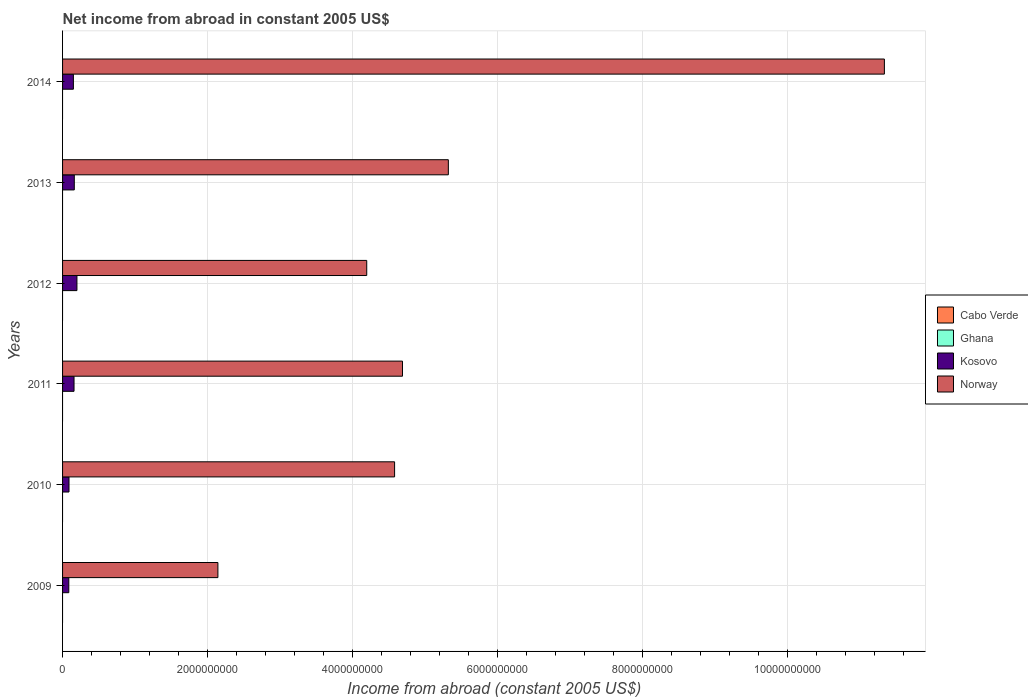Are the number of bars per tick equal to the number of legend labels?
Give a very brief answer. No. How many bars are there on the 3rd tick from the top?
Provide a short and direct response. 2. What is the label of the 2nd group of bars from the top?
Provide a succinct answer. 2013. Across all years, what is the maximum net income from abroad in Norway?
Make the answer very short. 1.13e+1. Across all years, what is the minimum net income from abroad in Kosovo?
Offer a very short reply. 8.59e+07. What is the total net income from abroad in Norway in the graph?
Your response must be concise. 3.22e+1. What is the difference between the net income from abroad in Norway in 2010 and that in 2014?
Your answer should be very brief. -6.75e+09. What is the difference between the net income from abroad in Kosovo in 2011 and the net income from abroad in Ghana in 2014?
Offer a terse response. 1.58e+08. What is the average net income from abroad in Ghana per year?
Offer a very short reply. 0. In the year 2014, what is the difference between the net income from abroad in Kosovo and net income from abroad in Norway?
Offer a terse response. -1.12e+1. In how many years, is the net income from abroad in Ghana greater than 2400000000 US$?
Make the answer very short. 0. What is the ratio of the net income from abroad in Norway in 2010 to that in 2012?
Provide a succinct answer. 1.09. What is the difference between the highest and the second highest net income from abroad in Norway?
Give a very brief answer. 6.01e+09. What is the difference between the highest and the lowest net income from abroad in Kosovo?
Your response must be concise. 1.12e+08. Is the sum of the net income from abroad in Norway in 2011 and 2014 greater than the maximum net income from abroad in Ghana across all years?
Keep it short and to the point. Yes. Is it the case that in every year, the sum of the net income from abroad in Norway and net income from abroad in Cabo Verde is greater than the sum of net income from abroad in Ghana and net income from abroad in Kosovo?
Make the answer very short. No. Is it the case that in every year, the sum of the net income from abroad in Kosovo and net income from abroad in Norway is greater than the net income from abroad in Cabo Verde?
Make the answer very short. Yes. How many bars are there?
Provide a short and direct response. 12. What is the difference between two consecutive major ticks on the X-axis?
Your response must be concise. 2.00e+09. Does the graph contain any zero values?
Ensure brevity in your answer.  Yes. What is the title of the graph?
Ensure brevity in your answer.  Net income from abroad in constant 2005 US$. What is the label or title of the X-axis?
Provide a short and direct response. Income from abroad (constant 2005 US$). What is the label or title of the Y-axis?
Provide a succinct answer. Years. What is the Income from abroad (constant 2005 US$) of Cabo Verde in 2009?
Ensure brevity in your answer.  0. What is the Income from abroad (constant 2005 US$) in Kosovo in 2009?
Give a very brief answer. 8.59e+07. What is the Income from abroad (constant 2005 US$) of Norway in 2009?
Your answer should be compact. 2.14e+09. What is the Income from abroad (constant 2005 US$) of Ghana in 2010?
Provide a succinct answer. 0. What is the Income from abroad (constant 2005 US$) of Kosovo in 2010?
Give a very brief answer. 8.88e+07. What is the Income from abroad (constant 2005 US$) in Norway in 2010?
Ensure brevity in your answer.  4.58e+09. What is the Income from abroad (constant 2005 US$) in Cabo Verde in 2011?
Give a very brief answer. 0. What is the Income from abroad (constant 2005 US$) in Ghana in 2011?
Provide a succinct answer. 0. What is the Income from abroad (constant 2005 US$) of Kosovo in 2011?
Provide a succinct answer. 1.58e+08. What is the Income from abroad (constant 2005 US$) in Norway in 2011?
Your answer should be very brief. 4.69e+09. What is the Income from abroad (constant 2005 US$) in Kosovo in 2012?
Your answer should be very brief. 1.98e+08. What is the Income from abroad (constant 2005 US$) of Norway in 2012?
Offer a terse response. 4.19e+09. What is the Income from abroad (constant 2005 US$) of Cabo Verde in 2013?
Offer a very short reply. 0. What is the Income from abroad (constant 2005 US$) in Ghana in 2013?
Provide a short and direct response. 0. What is the Income from abroad (constant 2005 US$) of Kosovo in 2013?
Provide a short and direct response. 1.62e+08. What is the Income from abroad (constant 2005 US$) in Norway in 2013?
Give a very brief answer. 5.32e+09. What is the Income from abroad (constant 2005 US$) of Ghana in 2014?
Offer a terse response. 0. What is the Income from abroad (constant 2005 US$) of Kosovo in 2014?
Your answer should be very brief. 1.49e+08. What is the Income from abroad (constant 2005 US$) in Norway in 2014?
Offer a very short reply. 1.13e+1. Across all years, what is the maximum Income from abroad (constant 2005 US$) in Kosovo?
Your response must be concise. 1.98e+08. Across all years, what is the maximum Income from abroad (constant 2005 US$) of Norway?
Offer a very short reply. 1.13e+1. Across all years, what is the minimum Income from abroad (constant 2005 US$) of Kosovo?
Your answer should be very brief. 8.59e+07. Across all years, what is the minimum Income from abroad (constant 2005 US$) in Norway?
Provide a short and direct response. 2.14e+09. What is the total Income from abroad (constant 2005 US$) of Ghana in the graph?
Offer a terse response. 0. What is the total Income from abroad (constant 2005 US$) of Kosovo in the graph?
Offer a very short reply. 8.42e+08. What is the total Income from abroad (constant 2005 US$) in Norway in the graph?
Your response must be concise. 3.22e+1. What is the difference between the Income from abroad (constant 2005 US$) of Kosovo in 2009 and that in 2010?
Make the answer very short. -2.94e+06. What is the difference between the Income from abroad (constant 2005 US$) of Norway in 2009 and that in 2010?
Offer a very short reply. -2.44e+09. What is the difference between the Income from abroad (constant 2005 US$) in Kosovo in 2009 and that in 2011?
Ensure brevity in your answer.  -7.23e+07. What is the difference between the Income from abroad (constant 2005 US$) of Norway in 2009 and that in 2011?
Provide a succinct answer. -2.54e+09. What is the difference between the Income from abroad (constant 2005 US$) of Kosovo in 2009 and that in 2012?
Offer a very short reply. -1.12e+08. What is the difference between the Income from abroad (constant 2005 US$) of Norway in 2009 and that in 2012?
Give a very brief answer. -2.05e+09. What is the difference between the Income from abroad (constant 2005 US$) in Kosovo in 2009 and that in 2013?
Make the answer very short. -7.58e+07. What is the difference between the Income from abroad (constant 2005 US$) in Norway in 2009 and that in 2013?
Provide a short and direct response. -3.18e+09. What is the difference between the Income from abroad (constant 2005 US$) in Kosovo in 2009 and that in 2014?
Your answer should be compact. -6.34e+07. What is the difference between the Income from abroad (constant 2005 US$) of Norway in 2009 and that in 2014?
Offer a very short reply. -9.19e+09. What is the difference between the Income from abroad (constant 2005 US$) of Kosovo in 2010 and that in 2011?
Keep it short and to the point. -6.94e+07. What is the difference between the Income from abroad (constant 2005 US$) in Norway in 2010 and that in 2011?
Provide a succinct answer. -1.09e+08. What is the difference between the Income from abroad (constant 2005 US$) of Kosovo in 2010 and that in 2012?
Your answer should be compact. -1.09e+08. What is the difference between the Income from abroad (constant 2005 US$) in Norway in 2010 and that in 2012?
Ensure brevity in your answer.  3.84e+08. What is the difference between the Income from abroad (constant 2005 US$) in Kosovo in 2010 and that in 2013?
Your answer should be compact. -7.29e+07. What is the difference between the Income from abroad (constant 2005 US$) in Norway in 2010 and that in 2013?
Provide a succinct answer. -7.41e+08. What is the difference between the Income from abroad (constant 2005 US$) in Kosovo in 2010 and that in 2014?
Your response must be concise. -6.05e+07. What is the difference between the Income from abroad (constant 2005 US$) in Norway in 2010 and that in 2014?
Give a very brief answer. -6.75e+09. What is the difference between the Income from abroad (constant 2005 US$) in Kosovo in 2011 and that in 2012?
Make the answer very short. -3.99e+07. What is the difference between the Income from abroad (constant 2005 US$) of Norway in 2011 and that in 2012?
Your response must be concise. 4.93e+08. What is the difference between the Income from abroad (constant 2005 US$) of Kosovo in 2011 and that in 2013?
Give a very brief answer. -3.47e+06. What is the difference between the Income from abroad (constant 2005 US$) in Norway in 2011 and that in 2013?
Your response must be concise. -6.32e+08. What is the difference between the Income from abroad (constant 2005 US$) of Kosovo in 2011 and that in 2014?
Your answer should be compact. 8.91e+06. What is the difference between the Income from abroad (constant 2005 US$) of Norway in 2011 and that in 2014?
Give a very brief answer. -6.64e+09. What is the difference between the Income from abroad (constant 2005 US$) of Kosovo in 2012 and that in 2013?
Give a very brief answer. 3.64e+07. What is the difference between the Income from abroad (constant 2005 US$) in Norway in 2012 and that in 2013?
Offer a very short reply. -1.13e+09. What is the difference between the Income from abroad (constant 2005 US$) of Kosovo in 2012 and that in 2014?
Your answer should be compact. 4.88e+07. What is the difference between the Income from abroad (constant 2005 US$) in Norway in 2012 and that in 2014?
Ensure brevity in your answer.  -7.14e+09. What is the difference between the Income from abroad (constant 2005 US$) in Kosovo in 2013 and that in 2014?
Give a very brief answer. 1.24e+07. What is the difference between the Income from abroad (constant 2005 US$) in Norway in 2013 and that in 2014?
Provide a short and direct response. -6.01e+09. What is the difference between the Income from abroad (constant 2005 US$) in Kosovo in 2009 and the Income from abroad (constant 2005 US$) in Norway in 2010?
Make the answer very short. -4.49e+09. What is the difference between the Income from abroad (constant 2005 US$) in Kosovo in 2009 and the Income from abroad (constant 2005 US$) in Norway in 2011?
Your response must be concise. -4.60e+09. What is the difference between the Income from abroad (constant 2005 US$) in Kosovo in 2009 and the Income from abroad (constant 2005 US$) in Norway in 2012?
Your response must be concise. -4.11e+09. What is the difference between the Income from abroad (constant 2005 US$) in Kosovo in 2009 and the Income from abroad (constant 2005 US$) in Norway in 2013?
Your answer should be very brief. -5.23e+09. What is the difference between the Income from abroad (constant 2005 US$) in Kosovo in 2009 and the Income from abroad (constant 2005 US$) in Norway in 2014?
Offer a very short reply. -1.12e+1. What is the difference between the Income from abroad (constant 2005 US$) of Kosovo in 2010 and the Income from abroad (constant 2005 US$) of Norway in 2011?
Keep it short and to the point. -4.60e+09. What is the difference between the Income from abroad (constant 2005 US$) in Kosovo in 2010 and the Income from abroad (constant 2005 US$) in Norway in 2012?
Provide a succinct answer. -4.10e+09. What is the difference between the Income from abroad (constant 2005 US$) in Kosovo in 2010 and the Income from abroad (constant 2005 US$) in Norway in 2013?
Your answer should be compact. -5.23e+09. What is the difference between the Income from abroad (constant 2005 US$) of Kosovo in 2010 and the Income from abroad (constant 2005 US$) of Norway in 2014?
Your answer should be compact. -1.12e+1. What is the difference between the Income from abroad (constant 2005 US$) of Kosovo in 2011 and the Income from abroad (constant 2005 US$) of Norway in 2012?
Ensure brevity in your answer.  -4.04e+09. What is the difference between the Income from abroad (constant 2005 US$) of Kosovo in 2011 and the Income from abroad (constant 2005 US$) of Norway in 2013?
Your response must be concise. -5.16e+09. What is the difference between the Income from abroad (constant 2005 US$) in Kosovo in 2011 and the Income from abroad (constant 2005 US$) in Norway in 2014?
Your response must be concise. -1.12e+1. What is the difference between the Income from abroad (constant 2005 US$) in Kosovo in 2012 and the Income from abroad (constant 2005 US$) in Norway in 2013?
Give a very brief answer. -5.12e+09. What is the difference between the Income from abroad (constant 2005 US$) in Kosovo in 2012 and the Income from abroad (constant 2005 US$) in Norway in 2014?
Make the answer very short. -1.11e+1. What is the difference between the Income from abroad (constant 2005 US$) in Kosovo in 2013 and the Income from abroad (constant 2005 US$) in Norway in 2014?
Ensure brevity in your answer.  -1.12e+1. What is the average Income from abroad (constant 2005 US$) of Ghana per year?
Give a very brief answer. 0. What is the average Income from abroad (constant 2005 US$) in Kosovo per year?
Give a very brief answer. 1.40e+08. What is the average Income from abroad (constant 2005 US$) in Norway per year?
Provide a succinct answer. 5.37e+09. In the year 2009, what is the difference between the Income from abroad (constant 2005 US$) of Kosovo and Income from abroad (constant 2005 US$) of Norway?
Keep it short and to the point. -2.06e+09. In the year 2010, what is the difference between the Income from abroad (constant 2005 US$) in Kosovo and Income from abroad (constant 2005 US$) in Norway?
Your answer should be very brief. -4.49e+09. In the year 2011, what is the difference between the Income from abroad (constant 2005 US$) of Kosovo and Income from abroad (constant 2005 US$) of Norway?
Offer a terse response. -4.53e+09. In the year 2012, what is the difference between the Income from abroad (constant 2005 US$) in Kosovo and Income from abroad (constant 2005 US$) in Norway?
Your answer should be very brief. -4.00e+09. In the year 2013, what is the difference between the Income from abroad (constant 2005 US$) of Kosovo and Income from abroad (constant 2005 US$) of Norway?
Your response must be concise. -5.16e+09. In the year 2014, what is the difference between the Income from abroad (constant 2005 US$) of Kosovo and Income from abroad (constant 2005 US$) of Norway?
Offer a very short reply. -1.12e+1. What is the ratio of the Income from abroad (constant 2005 US$) in Kosovo in 2009 to that in 2010?
Offer a terse response. 0.97. What is the ratio of the Income from abroad (constant 2005 US$) in Norway in 2009 to that in 2010?
Your response must be concise. 0.47. What is the ratio of the Income from abroad (constant 2005 US$) of Kosovo in 2009 to that in 2011?
Make the answer very short. 0.54. What is the ratio of the Income from abroad (constant 2005 US$) of Norway in 2009 to that in 2011?
Make the answer very short. 0.46. What is the ratio of the Income from abroad (constant 2005 US$) of Kosovo in 2009 to that in 2012?
Your answer should be very brief. 0.43. What is the ratio of the Income from abroad (constant 2005 US$) of Norway in 2009 to that in 2012?
Ensure brevity in your answer.  0.51. What is the ratio of the Income from abroad (constant 2005 US$) of Kosovo in 2009 to that in 2013?
Ensure brevity in your answer.  0.53. What is the ratio of the Income from abroad (constant 2005 US$) in Norway in 2009 to that in 2013?
Your answer should be compact. 0.4. What is the ratio of the Income from abroad (constant 2005 US$) in Kosovo in 2009 to that in 2014?
Give a very brief answer. 0.58. What is the ratio of the Income from abroad (constant 2005 US$) of Norway in 2009 to that in 2014?
Keep it short and to the point. 0.19. What is the ratio of the Income from abroad (constant 2005 US$) in Kosovo in 2010 to that in 2011?
Make the answer very short. 0.56. What is the ratio of the Income from abroad (constant 2005 US$) in Norway in 2010 to that in 2011?
Offer a very short reply. 0.98. What is the ratio of the Income from abroad (constant 2005 US$) of Kosovo in 2010 to that in 2012?
Your answer should be compact. 0.45. What is the ratio of the Income from abroad (constant 2005 US$) of Norway in 2010 to that in 2012?
Your answer should be compact. 1.09. What is the ratio of the Income from abroad (constant 2005 US$) of Kosovo in 2010 to that in 2013?
Offer a very short reply. 0.55. What is the ratio of the Income from abroad (constant 2005 US$) of Norway in 2010 to that in 2013?
Ensure brevity in your answer.  0.86. What is the ratio of the Income from abroad (constant 2005 US$) of Kosovo in 2010 to that in 2014?
Keep it short and to the point. 0.59. What is the ratio of the Income from abroad (constant 2005 US$) of Norway in 2010 to that in 2014?
Ensure brevity in your answer.  0.4. What is the ratio of the Income from abroad (constant 2005 US$) of Kosovo in 2011 to that in 2012?
Your response must be concise. 0.8. What is the ratio of the Income from abroad (constant 2005 US$) of Norway in 2011 to that in 2012?
Offer a terse response. 1.12. What is the ratio of the Income from abroad (constant 2005 US$) of Kosovo in 2011 to that in 2013?
Your answer should be compact. 0.98. What is the ratio of the Income from abroad (constant 2005 US$) in Norway in 2011 to that in 2013?
Provide a succinct answer. 0.88. What is the ratio of the Income from abroad (constant 2005 US$) of Kosovo in 2011 to that in 2014?
Ensure brevity in your answer.  1.06. What is the ratio of the Income from abroad (constant 2005 US$) of Norway in 2011 to that in 2014?
Your answer should be compact. 0.41. What is the ratio of the Income from abroad (constant 2005 US$) of Kosovo in 2012 to that in 2013?
Offer a very short reply. 1.23. What is the ratio of the Income from abroad (constant 2005 US$) in Norway in 2012 to that in 2013?
Offer a very short reply. 0.79. What is the ratio of the Income from abroad (constant 2005 US$) of Kosovo in 2012 to that in 2014?
Provide a short and direct response. 1.33. What is the ratio of the Income from abroad (constant 2005 US$) of Norway in 2012 to that in 2014?
Your answer should be very brief. 0.37. What is the ratio of the Income from abroad (constant 2005 US$) of Kosovo in 2013 to that in 2014?
Make the answer very short. 1.08. What is the ratio of the Income from abroad (constant 2005 US$) of Norway in 2013 to that in 2014?
Offer a very short reply. 0.47. What is the difference between the highest and the second highest Income from abroad (constant 2005 US$) in Kosovo?
Your response must be concise. 3.64e+07. What is the difference between the highest and the second highest Income from abroad (constant 2005 US$) of Norway?
Offer a terse response. 6.01e+09. What is the difference between the highest and the lowest Income from abroad (constant 2005 US$) of Kosovo?
Give a very brief answer. 1.12e+08. What is the difference between the highest and the lowest Income from abroad (constant 2005 US$) in Norway?
Give a very brief answer. 9.19e+09. 